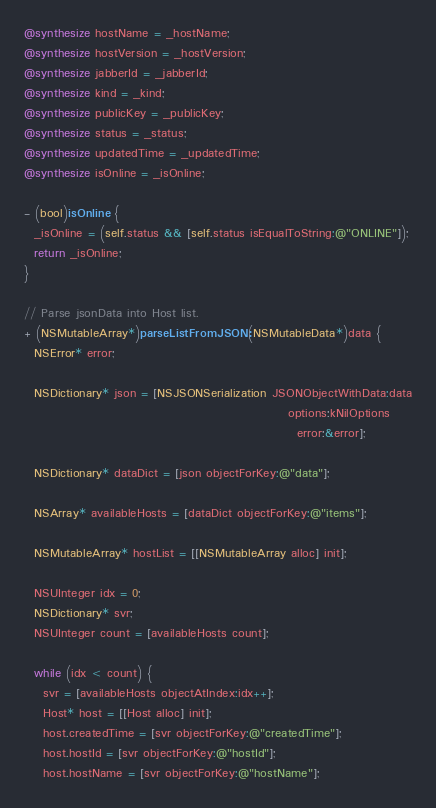<code> <loc_0><loc_0><loc_500><loc_500><_ObjectiveC_>@synthesize hostName = _hostName;
@synthesize hostVersion = _hostVersion;
@synthesize jabberId = _jabberId;
@synthesize kind = _kind;
@synthesize publicKey = _publicKey;
@synthesize status = _status;
@synthesize updatedTime = _updatedTime;
@synthesize isOnline = _isOnline;

- (bool)isOnline {
  _isOnline = (self.status && [self.status isEqualToString:@"ONLINE"]);
  return _isOnline;
}

// Parse jsonData into Host list.
+ (NSMutableArray*)parseListFromJSON:(NSMutableData*)data {
  NSError* error;

  NSDictionary* json = [NSJSONSerialization JSONObjectWithData:data
                                                       options:kNilOptions
                                                         error:&error];

  NSDictionary* dataDict = [json objectForKey:@"data"];

  NSArray* availableHosts = [dataDict objectForKey:@"items"];

  NSMutableArray* hostList = [[NSMutableArray alloc] init];

  NSUInteger idx = 0;
  NSDictionary* svr;
  NSUInteger count = [availableHosts count];

  while (idx < count) {
    svr = [availableHosts objectAtIndex:idx++];
    Host* host = [[Host alloc] init];
    host.createdTime = [svr objectForKey:@"createdTime"];
    host.hostId = [svr objectForKey:@"hostId"];
    host.hostName = [svr objectForKey:@"hostName"];</code> 